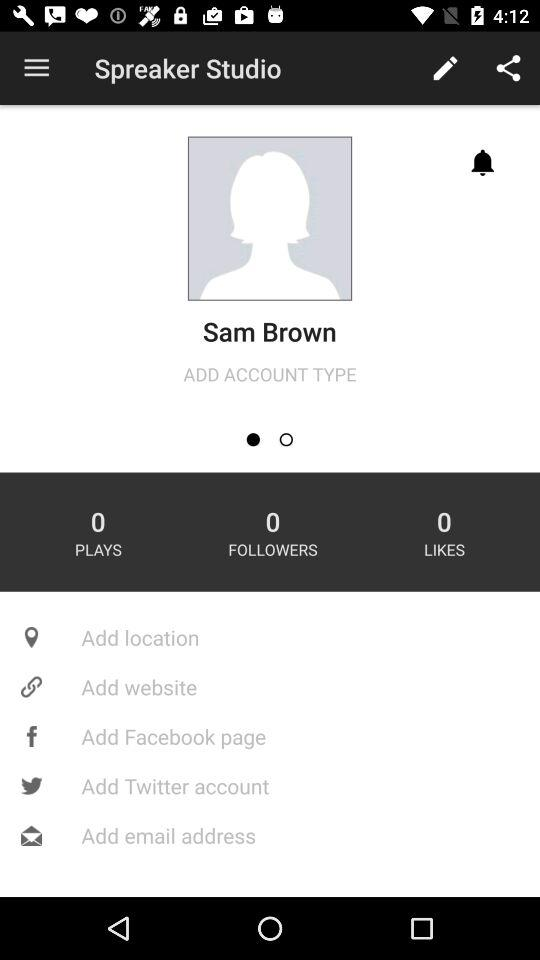How many likes does the person get? The person got 0 likes. 